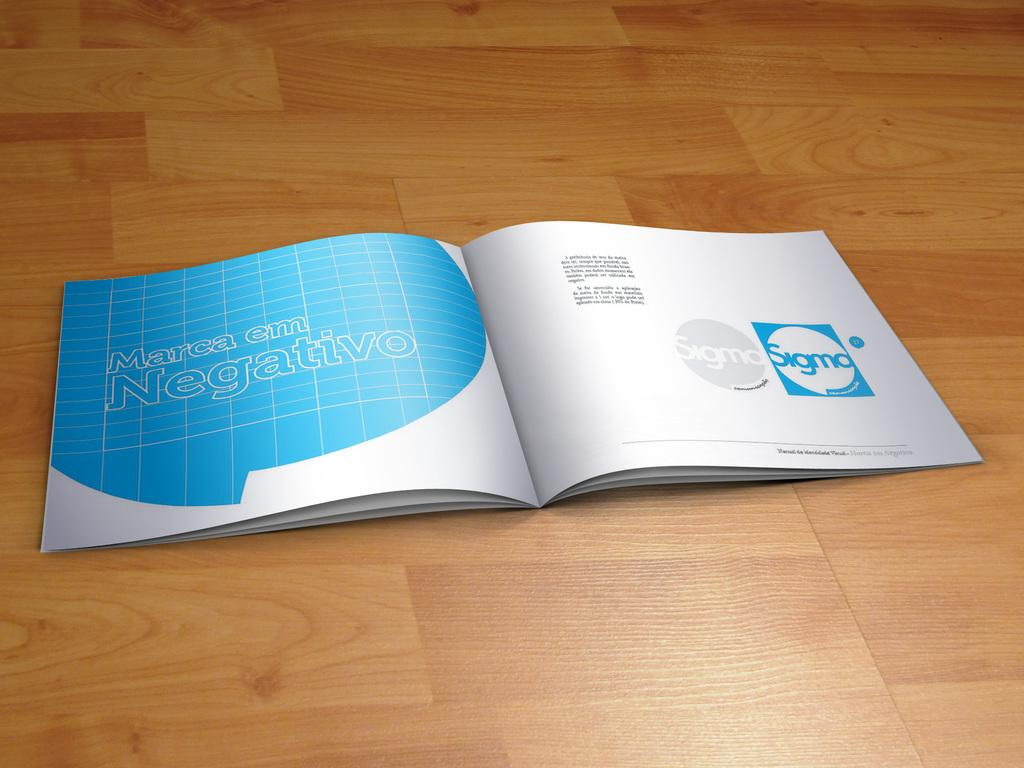<image>
Relay a brief, clear account of the picture shown. Open book on a page that says "Marca em Negativo". 